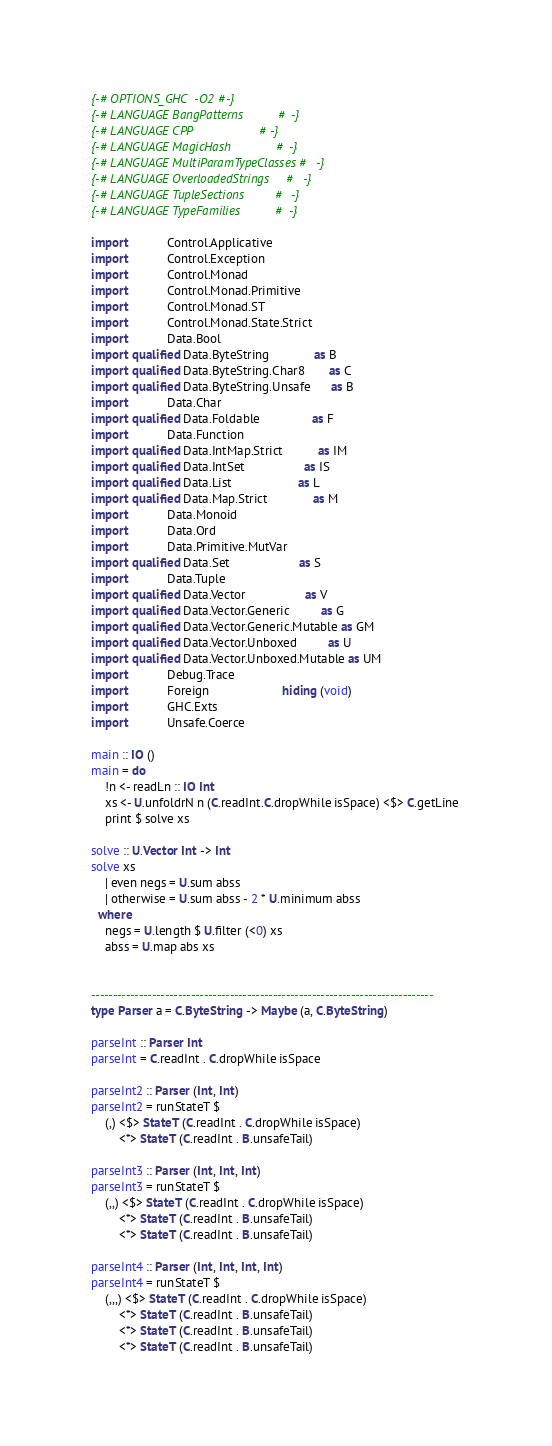<code> <loc_0><loc_0><loc_500><loc_500><_Haskell_>{-# OPTIONS_GHC -O2 #-}
{-# LANGUAGE BangPatterns          #-}
{-# LANGUAGE CPP                   #-}
{-# LANGUAGE MagicHash             #-}
{-# LANGUAGE MultiParamTypeClasses #-}
{-# LANGUAGE OverloadedStrings     #-}
{-# LANGUAGE TupleSections         #-}
{-# LANGUAGE TypeFamilies          #-}

import           Control.Applicative
import           Control.Exception
import           Control.Monad
import           Control.Monad.Primitive
import           Control.Monad.ST
import           Control.Monad.State.Strict
import           Data.Bool
import qualified Data.ByteString             as B
import qualified Data.ByteString.Char8       as C
import qualified Data.ByteString.Unsafe      as B
import           Data.Char
import qualified Data.Foldable               as F
import           Data.Function
import qualified Data.IntMap.Strict          as IM
import qualified Data.IntSet                 as IS
import qualified Data.List                   as L
import qualified Data.Map.Strict             as M
import           Data.Monoid
import           Data.Ord
import           Data.Primitive.MutVar
import qualified Data.Set                    as S
import           Data.Tuple
import qualified Data.Vector                 as V
import qualified Data.Vector.Generic         as G
import qualified Data.Vector.Generic.Mutable as GM
import qualified Data.Vector.Unboxed         as U
import qualified Data.Vector.Unboxed.Mutable as UM
import           Debug.Trace
import           Foreign                     hiding (void)
import           GHC.Exts
import           Unsafe.Coerce

main :: IO ()
main = do
    !n <- readLn :: IO Int
    xs <- U.unfoldrN n (C.readInt.C.dropWhile isSpace) <$> C.getLine
    print $ solve xs

solve :: U.Vector Int -> Int
solve xs
    | even negs = U.sum abss
    | otherwise = U.sum abss - 2 * U.minimum abss
  where
    negs = U.length $ U.filter (<0) xs
    abss = U.map abs xs


-------------------------------------------------------------------------------
type Parser a = C.ByteString -> Maybe (a, C.ByteString)

parseInt :: Parser Int
parseInt = C.readInt . C.dropWhile isSpace

parseInt2 :: Parser (Int, Int)
parseInt2 = runStateT $
    (,) <$> StateT (C.readInt . C.dropWhile isSpace)
        <*> StateT (C.readInt . B.unsafeTail)

parseInt3 :: Parser (Int, Int, Int)
parseInt3 = runStateT $
    (,,) <$> StateT (C.readInt . C.dropWhile isSpace)
        <*> StateT (C.readInt . B.unsafeTail)
        <*> StateT (C.readInt . B.unsafeTail)

parseInt4 :: Parser (Int, Int, Int, Int)
parseInt4 = runStateT $
    (,,,) <$> StateT (C.readInt . C.dropWhile isSpace)
        <*> StateT (C.readInt . B.unsafeTail)
        <*> StateT (C.readInt . B.unsafeTail)
        <*> StateT (C.readInt . B.unsafeTail)</code> 